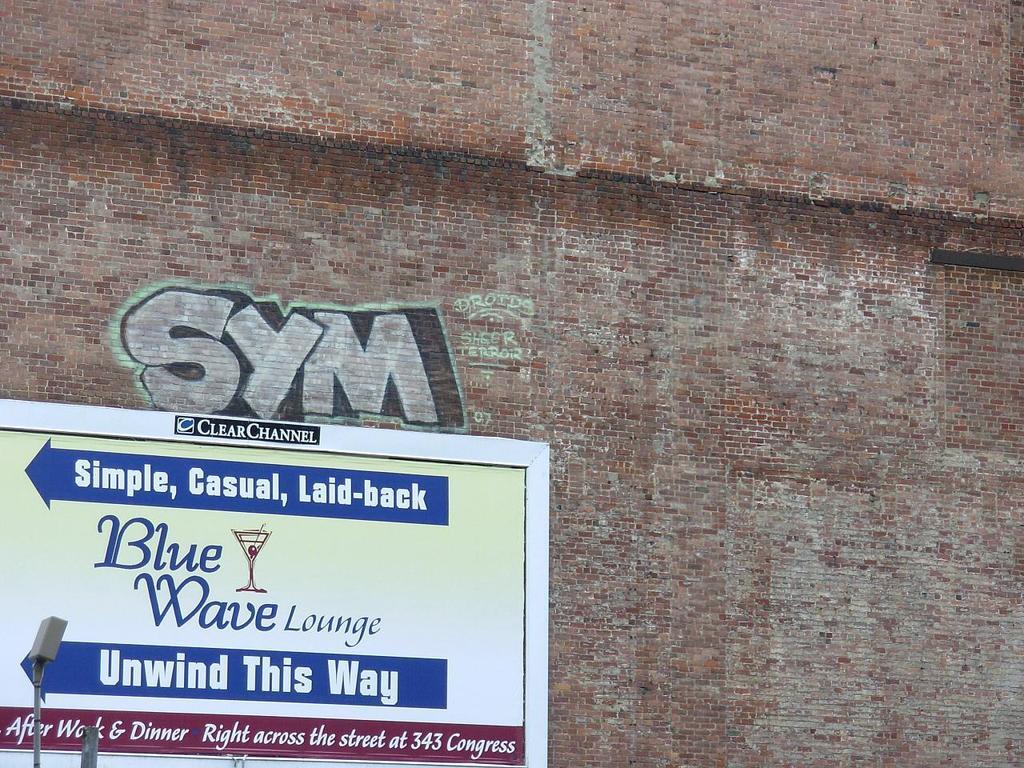Can you describe this image briefly? In the foreground of this image, there is a board on a brick wall and we can also see some text. 